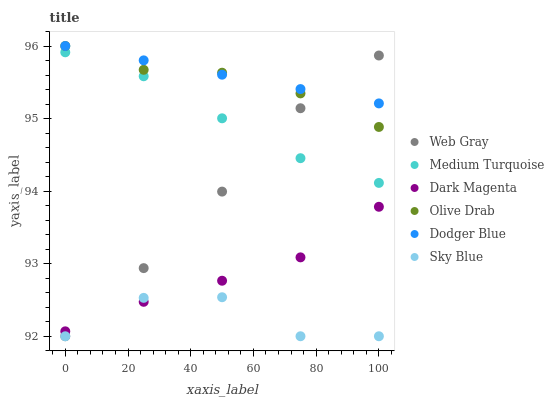Does Sky Blue have the minimum area under the curve?
Answer yes or no. Yes. Does Dodger Blue have the maximum area under the curve?
Answer yes or no. Yes. Does Dark Magenta have the minimum area under the curve?
Answer yes or no. No. Does Dark Magenta have the maximum area under the curve?
Answer yes or no. No. Is Dodger Blue the smoothest?
Answer yes or no. Yes. Is Sky Blue the roughest?
Answer yes or no. Yes. Is Dark Magenta the smoothest?
Answer yes or no. No. Is Dark Magenta the roughest?
Answer yes or no. No. Does Web Gray have the lowest value?
Answer yes or no. Yes. Does Dark Magenta have the lowest value?
Answer yes or no. No. Does Olive Drab have the highest value?
Answer yes or no. Yes. Does Dark Magenta have the highest value?
Answer yes or no. No. Is Sky Blue less than Dodger Blue?
Answer yes or no. Yes. Is Dodger Blue greater than Sky Blue?
Answer yes or no. Yes. Does Web Gray intersect Dodger Blue?
Answer yes or no. Yes. Is Web Gray less than Dodger Blue?
Answer yes or no. No. Is Web Gray greater than Dodger Blue?
Answer yes or no. No. Does Sky Blue intersect Dodger Blue?
Answer yes or no. No. 